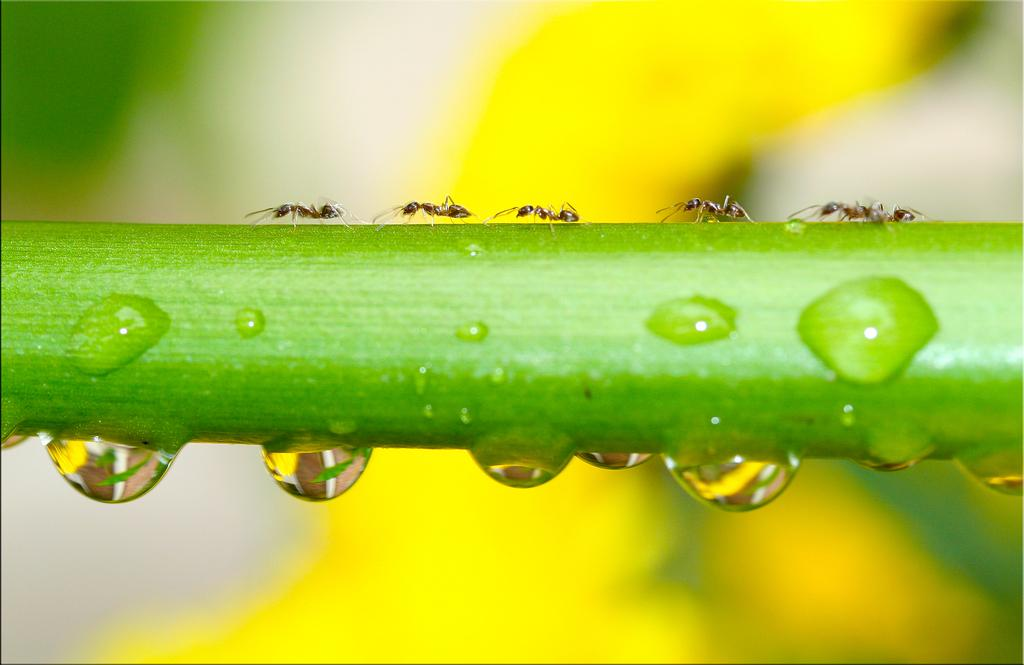What creatures can be seen on the stem in the image? There are ants on the stem in the image. What else can be observed in the image besides the ants? There are water droplets visible in the image. What type of statement can be seen in the image? There is no statement present in the image; it features ants on a stem and water droplets. Can you see any fish in the image? There are no fish present in the image. 